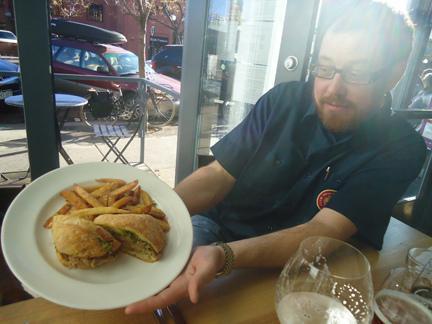How many sandwiches can be seen?
Give a very brief answer. 2. 